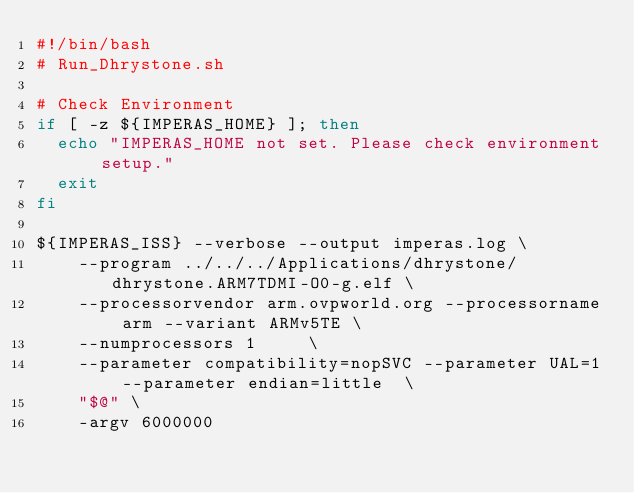<code> <loc_0><loc_0><loc_500><loc_500><_Bash_>#!/bin/bash
# Run_Dhrystone.sh

# Check Environment
if [ -z ${IMPERAS_HOME} ]; then
  echo "IMPERAS_HOME not set. Please check environment setup."
  exit
fi

${IMPERAS_ISS} --verbose --output imperas.log \
    --program ../../../Applications/dhrystone/dhrystone.ARM7TDMI-O0-g.elf \
    --processorvendor arm.ovpworld.org --processorname arm --variant ARMv5TE \
    --numprocessors 1     \
    --parameter compatibility=nopSVC --parameter UAL=1 --parameter endian=little  \
    "$@" \
    -argv 6000000

</code> 